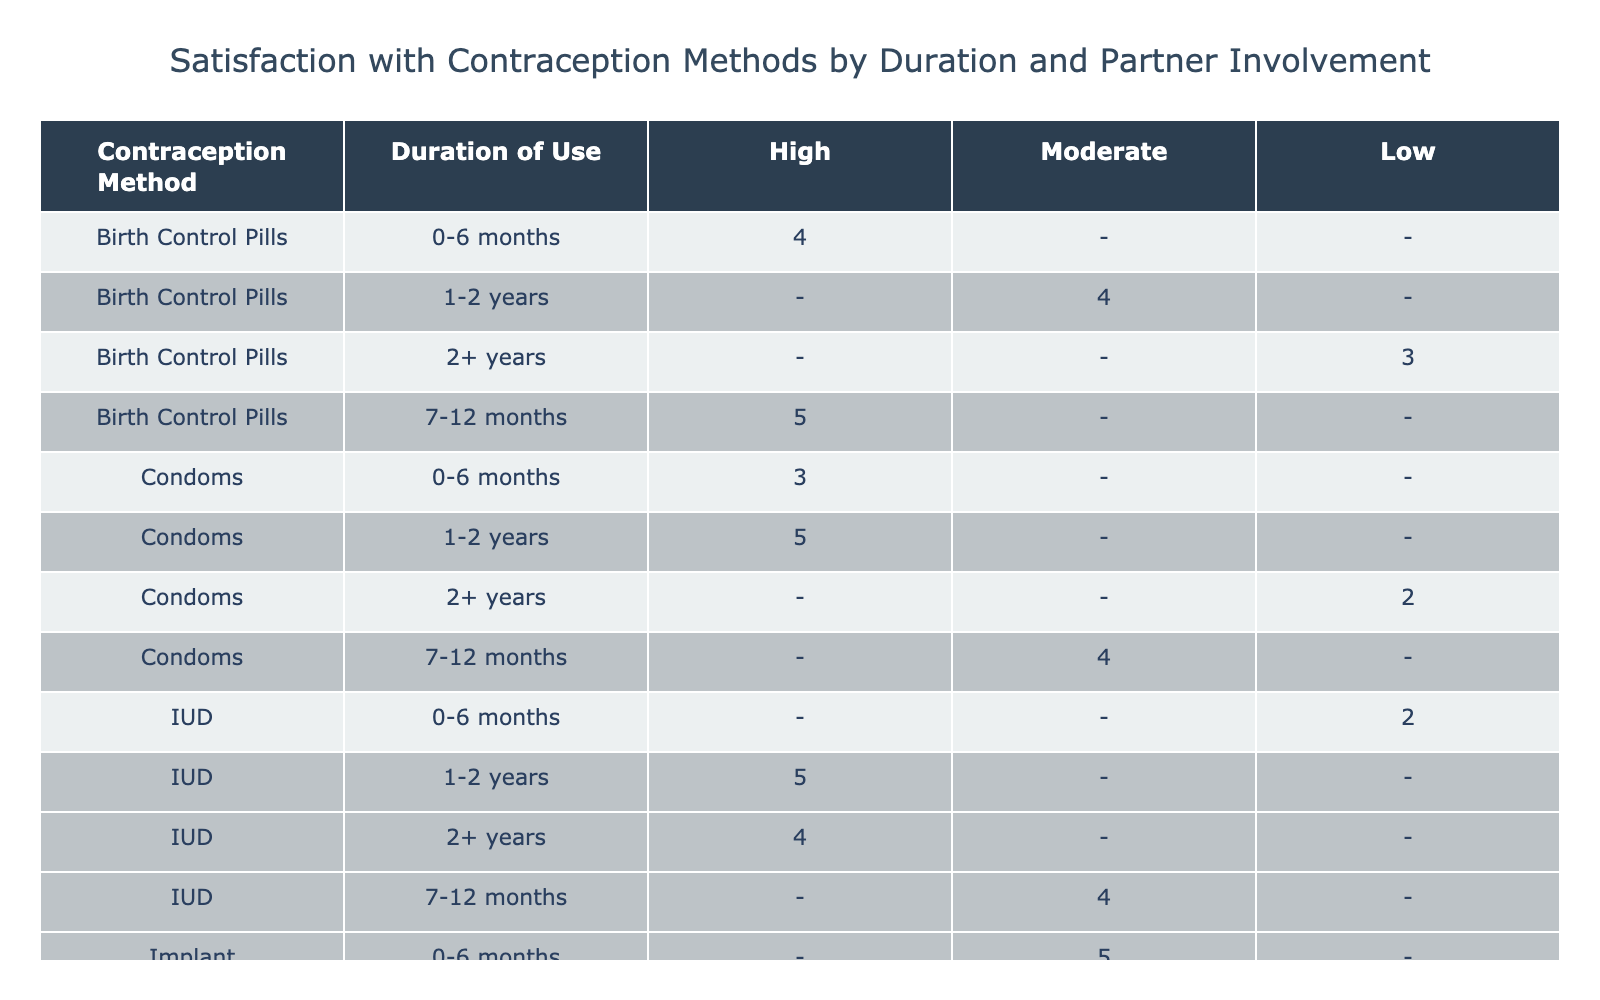What is the satisfaction level for Birth Control Pills used for over 2 years with low partner involvement? According to the table, the satisfaction level for Birth Control Pills when used for more than 2 years and with low partner involvement is 3.
Answer: 3 What is the highest satisfaction level recorded for the IUD in any duration of use? The table shows that the highest satisfaction level for the IUD is 5, which occurs within the 1-2 years duration at high partner involvement.
Answer: 5 Is the satisfaction level for Condoms with high partner involvement higher than for Withdrawal with low partner involvement? For Condoms with high partner involvement, the satisfaction level is 5, while for Withdrawal with low partner involvement, it is 2. Hence, yes, it is higher.
Answer: Yes What is the average satisfaction level for the Implant across all durations of use? The satisfaction levels for Implant are 5 (0-6 months), 4 (7-12 months), 3 (1-2 years), and 5 (2+ years). The sum is 5 + 4 + 3 + 5 = 17, and dividing by 4 gives an average of 17/4 = 4.25.
Answer: 4.25 Which contraceptive method has the lowest satisfaction level in the table? Looking through the satisfaction levels, the lowest satisfaction level recorded is 2, which applies to both IUD at 0-6 months with low involvement and Withdrawal at 1-2 years with low involvement.
Answer: 2 What is the satisfaction level for IUD used for 7-12 months with moderate partner involvement? In the table, the satisfaction level for IUD used for 7-12 months at moderate partner involvement is 4.
Answer: 4 Does the satisfaction level increase or decrease for Withdrawal as the duration of use increases? The satisfaction levels for Withdrawal are 3 (0-6 months), 3 (7-12 months), 2 (1-2 years), and 2 (2+ years). Since the satisfaction is decreasing over time, the answer is decrease.
Answer: Decrease What is the difference between the highest and lowest satisfaction levels for the Contraception Method 'Implant'? The highest satisfaction level for Implant is 5 (both at 0-6 months and 2+ years), and the lowest is 3 (at 1-2 years). The difference is 5 - 3 = 2.
Answer: 2 